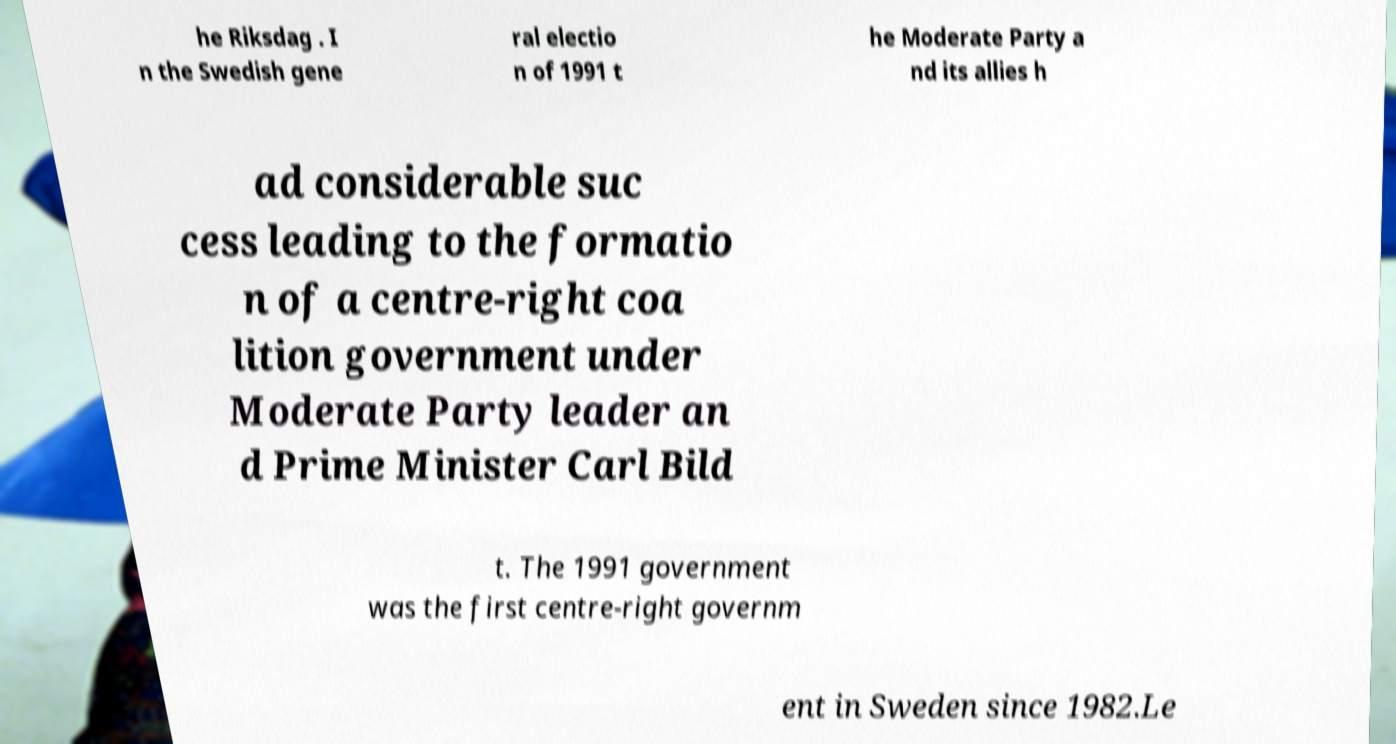For documentation purposes, I need the text within this image transcribed. Could you provide that? he Riksdag . I n the Swedish gene ral electio n of 1991 t he Moderate Party a nd its allies h ad considerable suc cess leading to the formatio n of a centre-right coa lition government under Moderate Party leader an d Prime Minister Carl Bild t. The 1991 government was the first centre-right governm ent in Sweden since 1982.Le 